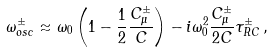Convert formula to latex. <formula><loc_0><loc_0><loc_500><loc_500>\omega _ { o s c } ^ { \pm } \approx \omega _ { 0 } \left ( 1 - \frac { 1 } { 2 } \frac { C _ { \mu } ^ { \pm } } { C } \right ) - i \omega _ { 0 } ^ { 2 } \frac { C _ { \mu } ^ { \pm } } { 2 C } \tau _ { R C } ^ { \pm } \, ,</formula> 